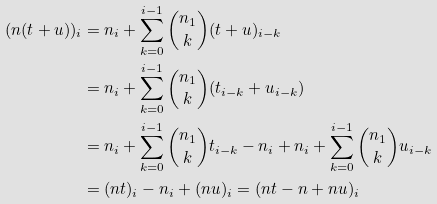Convert formula to latex. <formula><loc_0><loc_0><loc_500><loc_500>( n ( t + u ) ) _ { i } & = n _ { i } + \sum _ { k = 0 } ^ { i - 1 } \binom { n _ { 1 } } { k } ( t + u ) _ { i - k } \\ & = n _ { i } + \sum _ { k = 0 } ^ { i - 1 } \binom { n _ { 1 } } { k } ( t _ { i - k } + u _ { i - k } ) \\ & = n _ { i } + \sum _ { k = 0 } ^ { i - 1 } \binom { n _ { 1 } } { k } t _ { i - k } - n _ { i } + n _ { i } + \sum _ { k = 0 } ^ { i - 1 } \binom { n _ { 1 } } { k } u _ { i - k } \\ & = ( n t ) _ { i } - n _ { i } + ( n u ) _ { i } = ( n t - n + n u ) _ { i }</formula> 